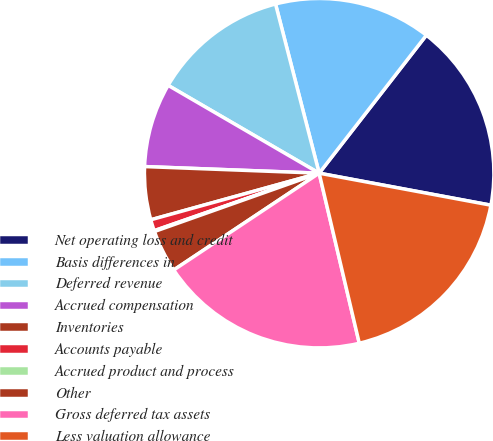Convert chart to OTSL. <chart><loc_0><loc_0><loc_500><loc_500><pie_chart><fcel>Net operating loss and credit<fcel>Basis differences in<fcel>Deferred revenue<fcel>Accrued compensation<fcel>Inventories<fcel>Accounts payable<fcel>Accrued product and process<fcel>Other<fcel>Gross deferred tax assets<fcel>Less valuation allowance<nl><fcel>17.42%<fcel>14.53%<fcel>12.6%<fcel>7.78%<fcel>4.9%<fcel>1.04%<fcel>0.08%<fcel>3.93%<fcel>19.34%<fcel>18.38%<nl></chart> 